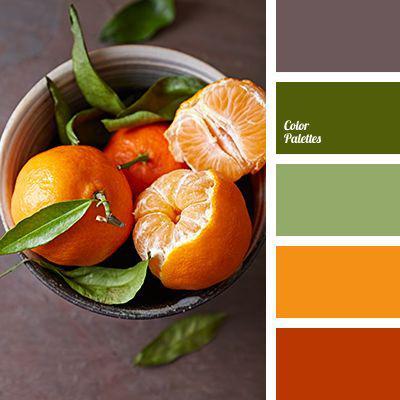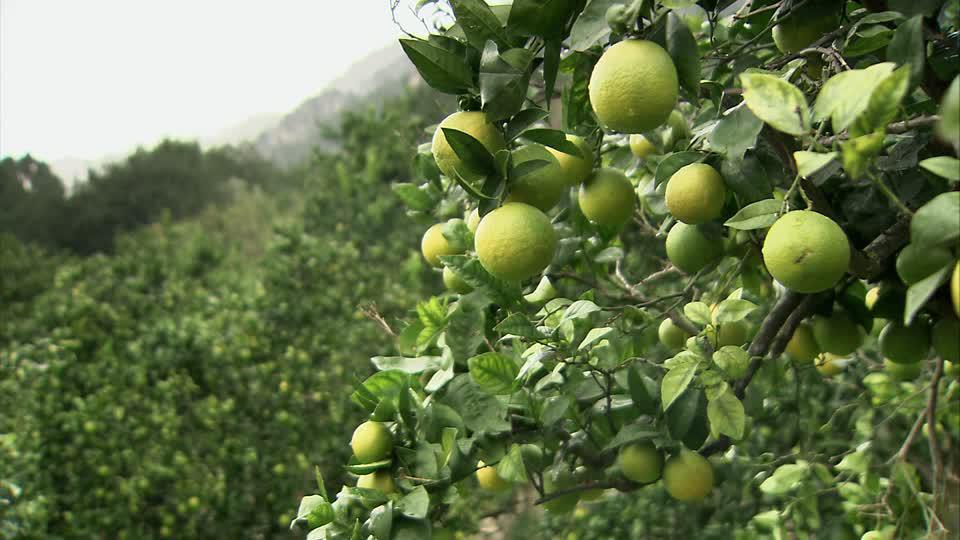The first image is the image on the left, the second image is the image on the right. Analyze the images presented: Is the assertion "A fruit with a green skin is revealing an orange inside in one of the images." valid? Answer yes or no. No. 